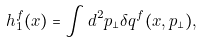<formula> <loc_0><loc_0><loc_500><loc_500>h _ { 1 } ^ { f } ( x ) = \int d ^ { 2 } p _ { \perp } \delta q ^ { f } ( x , { p } _ { \perp } ) ,</formula> 